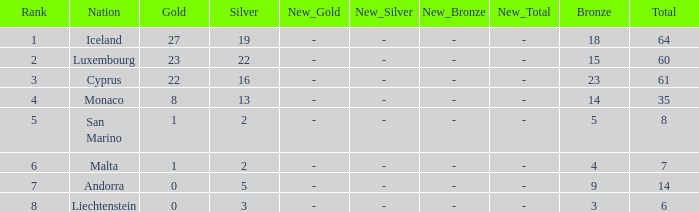Where does Iceland rank with under 19 silvers? None. 